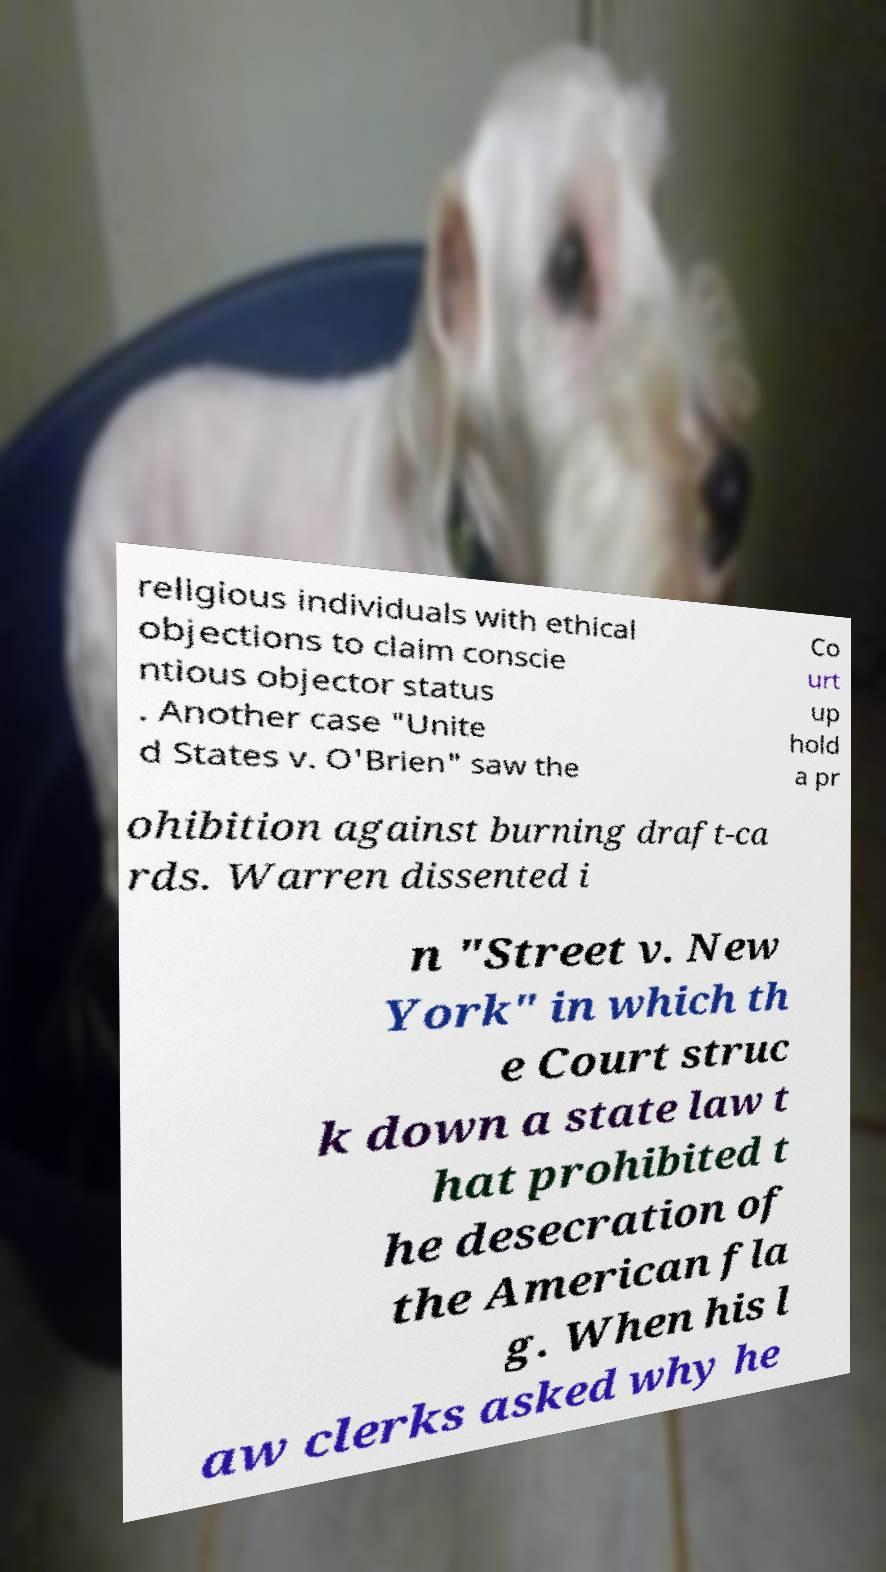What messages or text are displayed in this image? I need them in a readable, typed format. religious individuals with ethical objections to claim conscie ntious objector status . Another case "Unite d States v. O'Brien" saw the Co urt up hold a pr ohibition against burning draft-ca rds. Warren dissented i n "Street v. New York" in which th e Court struc k down a state law t hat prohibited t he desecration of the American fla g. When his l aw clerks asked why he 